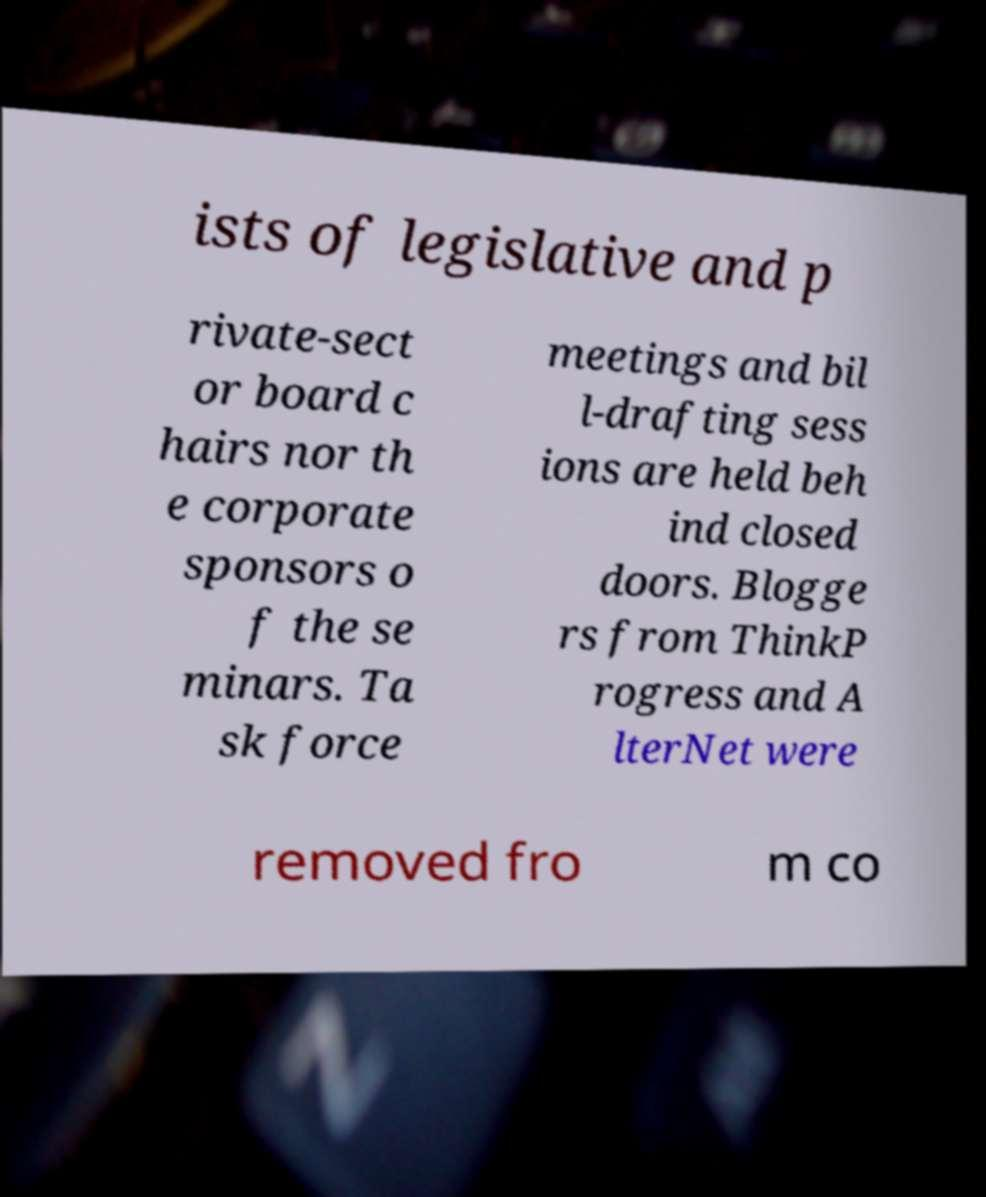Please identify and transcribe the text found in this image. ists of legislative and p rivate-sect or board c hairs nor th e corporate sponsors o f the se minars. Ta sk force meetings and bil l-drafting sess ions are held beh ind closed doors. Blogge rs from ThinkP rogress and A lterNet were removed fro m co 